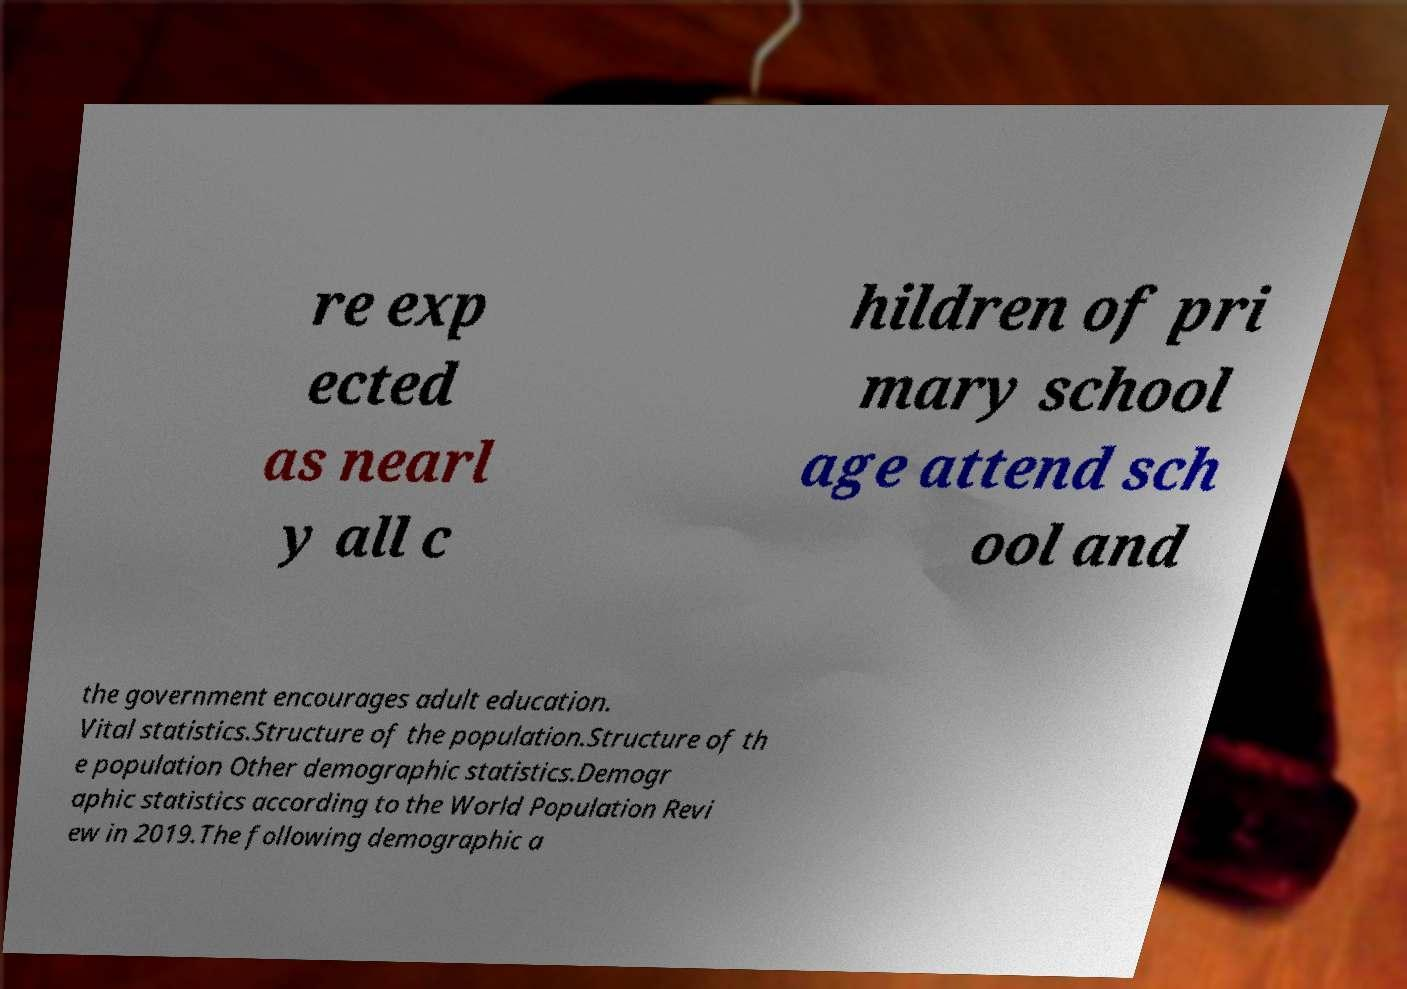What messages or text are displayed in this image? I need them in a readable, typed format. re exp ected as nearl y all c hildren of pri mary school age attend sch ool and the government encourages adult education. Vital statistics.Structure of the population.Structure of th e population Other demographic statistics.Demogr aphic statistics according to the World Population Revi ew in 2019.The following demographic a 